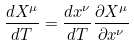<formula> <loc_0><loc_0><loc_500><loc_500>\frac { d X ^ { \mu } } { d T } = \frac { d x ^ { \nu } } { d T } \frac { \partial X ^ { \mu } } { \partial x ^ { \nu } }</formula> 